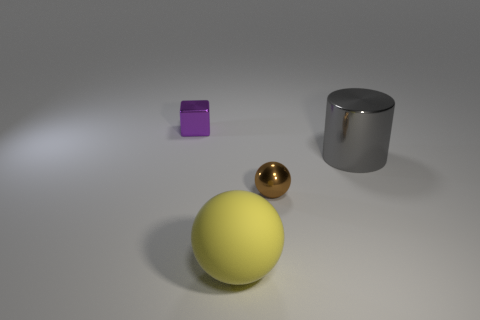Add 3 metal cylinders. How many objects exist? 7 Subtract all cubes. How many objects are left? 3 Subtract 0 gray balls. How many objects are left? 4 Subtract all tiny purple rubber blocks. Subtract all matte balls. How many objects are left? 3 Add 3 large cylinders. How many large cylinders are left? 4 Add 1 tiny metallic cubes. How many tiny metallic cubes exist? 2 